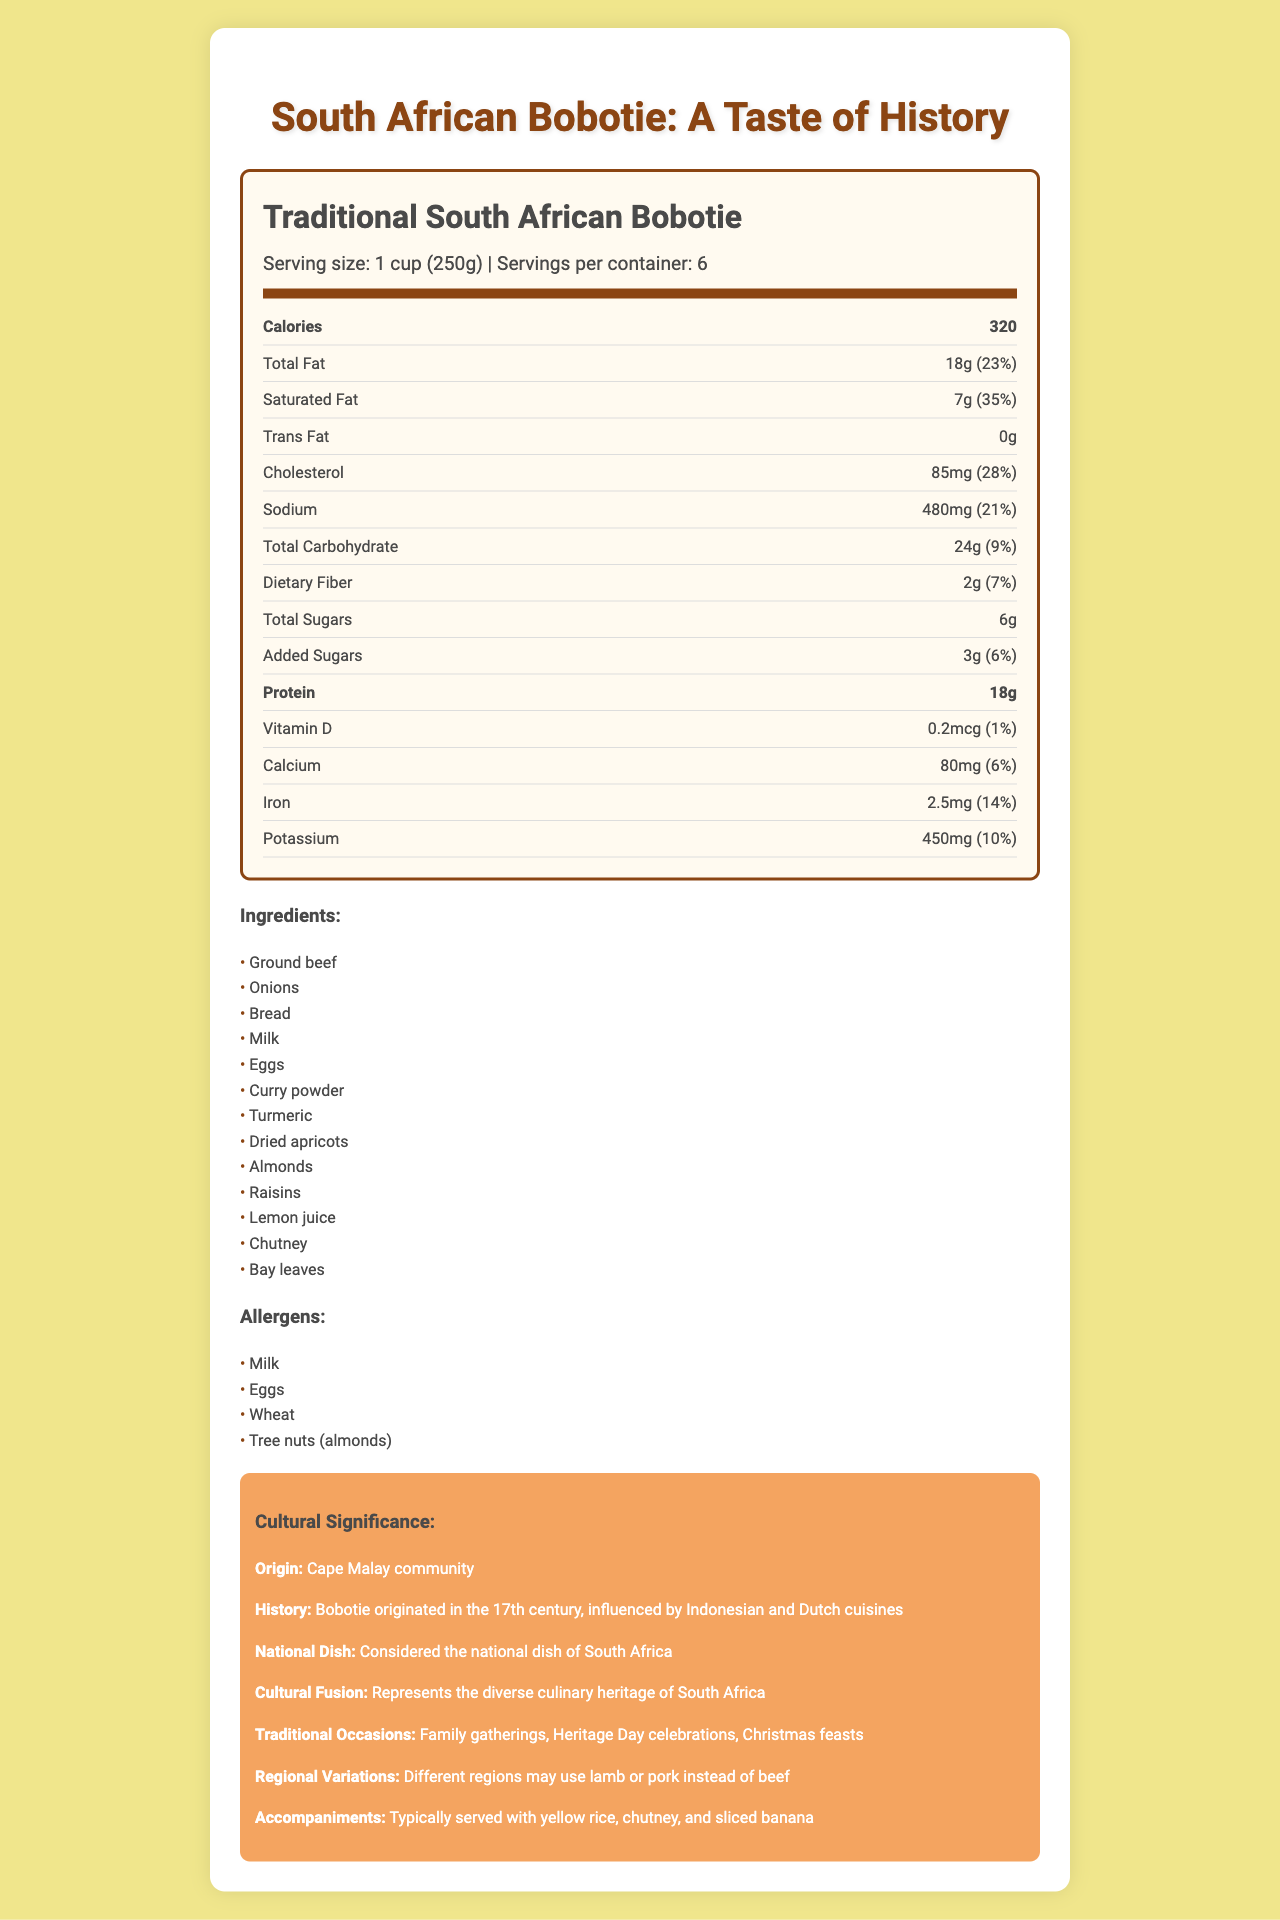what is the serving size for Traditional South African Bobotie? The serving size is clearly stated at the top of the nutrition label as "1 cup (250g)".
Answer: 1 cup (250g) how many calories are there per serving? The document lists the calories per serving as 320.
Answer: 320 calories what percentage of daily value is the total fat in one serving of Bobotie? Next to the total fat amount of "18g", the daily value percentage is listed as 23%.
Answer: 23% which community is the origin of Bobotie? The cultural significance section of the document states that the origin of Bobotie is the Cape Malay community.
Answer: Cape Malay community list some of the ingredients found in Bobotie. The ingredients are listed in a section under the Nutrition Facts label.
Answer: Ground beef, Onions, Bread, Milk, Eggs, Curry powder, Turmeric, Dried apricots, Almonds, Raisins, Lemon juice, Chutney, Bay leaves what occasions is Bobotie typically served on? The traditional occasions section lists these occasions.
Answer: Family gatherings, Heritage Day celebrations, Christmas feasts what are the allergens present in Bobotie? The allergens are listed specifically in the allergens section.
Answer: Milk, Eggs, Wheat, Tree nuts (almonds) what does the nutrient row showing 'Iron' indicate in terms of daily value percentage? Next to the iron amount of "2.5mg", the daily value percentage is stated as 14%.
Answer: 14% how much sodium does one serving of Bobotie contain? The sodium content is listed as "480mg".
Answer: 480mg which of the following is not an ingredient in Bobotie? A. Tomatoes B. Raisins C. Ground beef D. Lemon juice The list of ingredients does not include tomatoes.
Answer: A. Tomatoes which nutrient has the highest daily value percentage in one serving of Bobotie? A. Saturated Fat B. Iron C. Vitamin D D. Dietary Fiber Saturated fat has the highest daily value percentage at 35%.
Answer: A. Saturated Fat is Bobotie considered the national dish of South Africa? The cultural significance section explicitly states that Bobotie is considered the national dish of South Africa.
Answer: Yes explain the historical influence on Bobotie. The document mentions these historical influences in the cultural significance and historical context sections.
Answer: Bobotie originated in the 17th century and was influenced by Indonesian and Dutch cuisines. It reflects the colonial impact of the Dutch and the Malaysian slaves on South African cuisine. how much dietary fiber does one serving offer? The dietary fiber content is listed as "2g".
Answer: 2g is the cholesterol content in one serving greater than the acceptable daily intake for a person on a 2000-calorie diet? The document does not provide information on the acceptable daily intake of cholesterol for a specific diet.
Answer: Cannot be determined summarize the document content. The summary captures the main ideas and detailed content sections of the document, covering nutrition facts, cultural significance, ingredients, and allergens.
Answer: The document provides the nutrition facts for Traditional South African Bobotie, including serving size, calories, and nutrient amounts. It also lists the ingredients, allergens, and the cultural significance of Bobotie, noting its origins, historical influences, role as a national dish, traditional occasions, regional variations, and typical accompaniments. Finally, it highlights its balanced nutritional profile, protein content, and health benefits from spices and fruit content. 